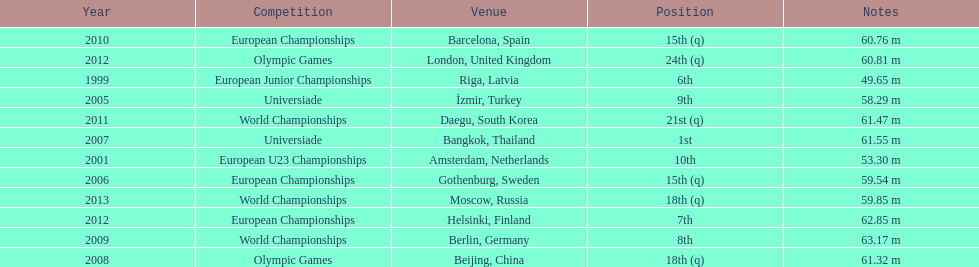Name two events in which mayer competed before he won the bangkok universiade. European Championships, Universiade. 